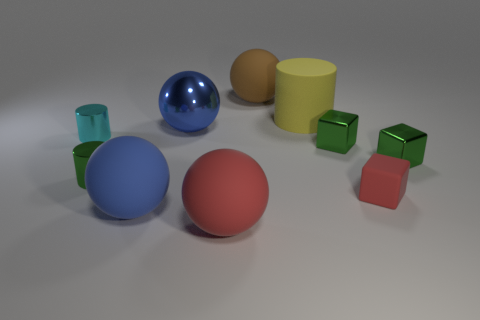Subtract all green cubes. How many were subtracted if there are1green cubes left? 1 Subtract 1 spheres. How many spheres are left? 3 Subtract all balls. How many objects are left? 6 Add 5 brown metallic spheres. How many brown metallic spheres exist? 5 Subtract 1 green cubes. How many objects are left? 9 Subtract all yellow matte cylinders. Subtract all large matte objects. How many objects are left? 5 Add 4 cylinders. How many cylinders are left? 7 